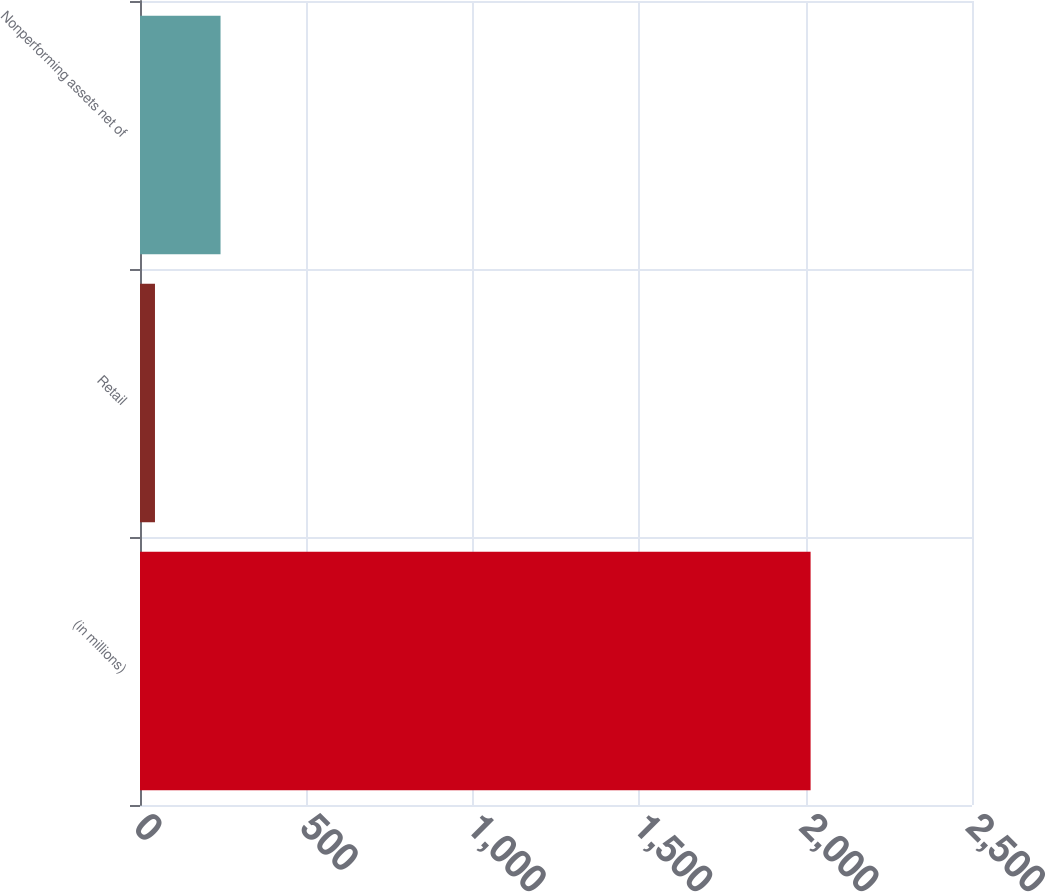Convert chart. <chart><loc_0><loc_0><loc_500><loc_500><bar_chart><fcel>(in millions)<fcel>Retail<fcel>Nonperforming assets net of<nl><fcel>2015<fcel>45<fcel>242<nl></chart> 